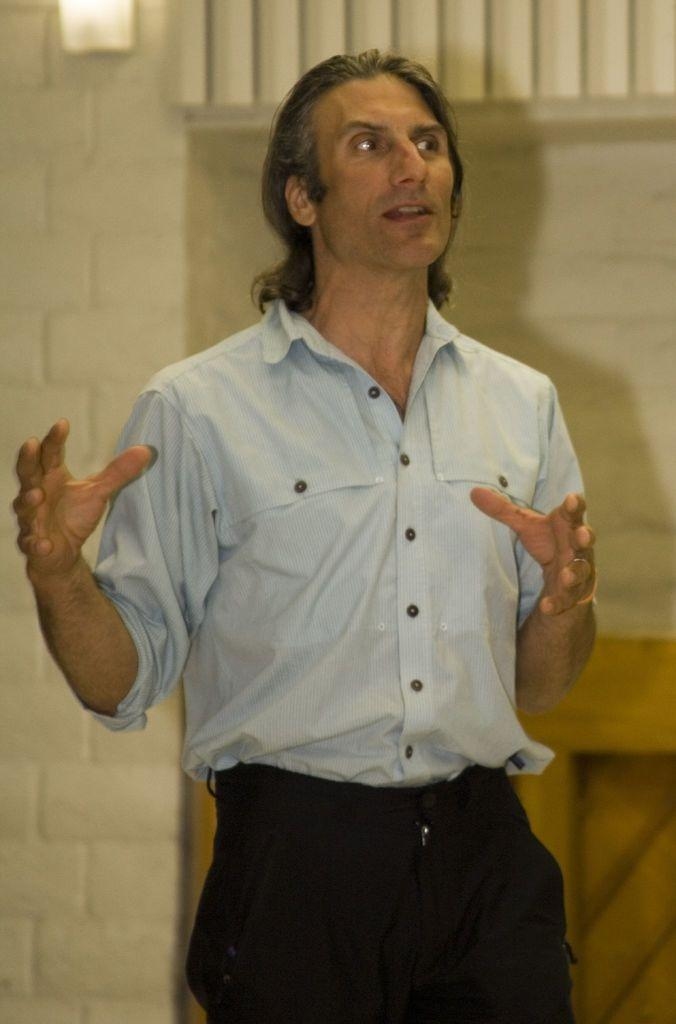What is the main subject of the image? There is a man standing in the image. Can you describe any features of the background in the image? There is a light on the wall in the background of the image. Are there any other objects visible in the background? Yes, there are other objects visible in the background of the image. How many screws are visible on the man's shirt in the image? There are no screws visible on the man's shirt in the image. What type of powder is being used by the man in the image? There is no powder present in the image, and the man is not using any. 